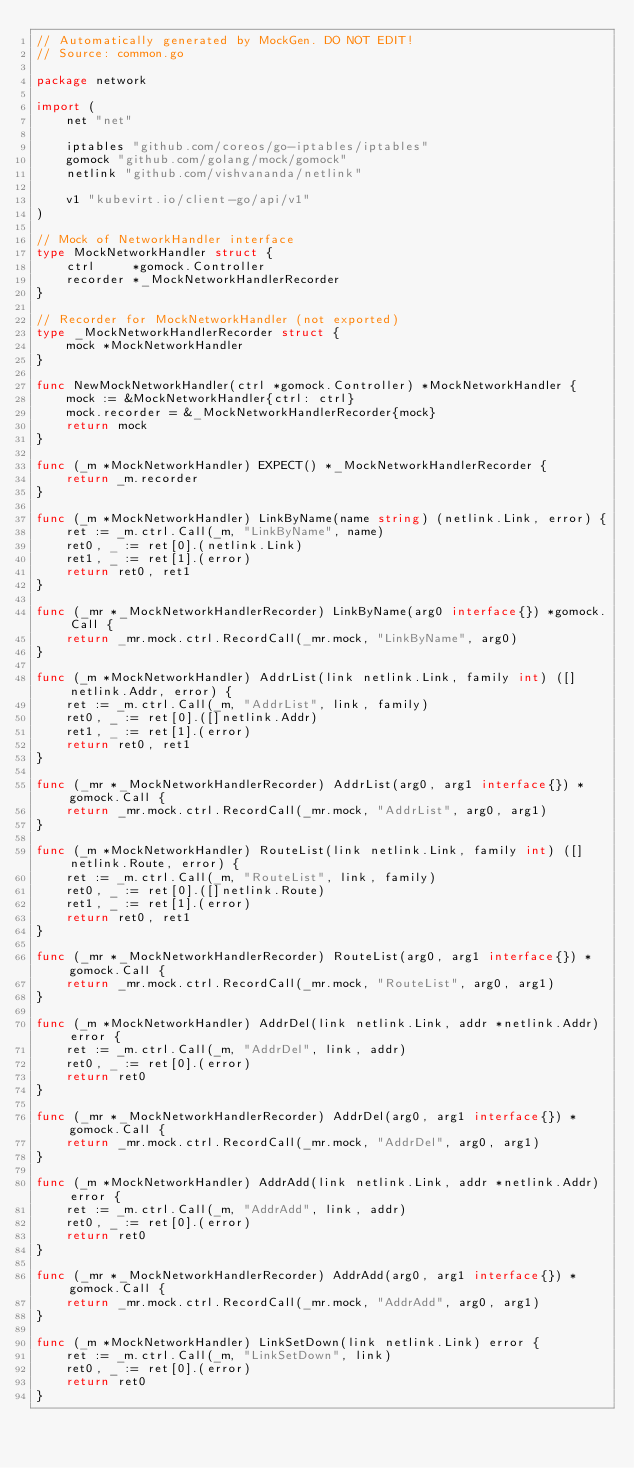<code> <loc_0><loc_0><loc_500><loc_500><_Go_>// Automatically generated by MockGen. DO NOT EDIT!
// Source: common.go

package network

import (
	net "net"

	iptables "github.com/coreos/go-iptables/iptables"
	gomock "github.com/golang/mock/gomock"
	netlink "github.com/vishvananda/netlink"

	v1 "kubevirt.io/client-go/api/v1"
)

// Mock of NetworkHandler interface
type MockNetworkHandler struct {
	ctrl     *gomock.Controller
	recorder *_MockNetworkHandlerRecorder
}

// Recorder for MockNetworkHandler (not exported)
type _MockNetworkHandlerRecorder struct {
	mock *MockNetworkHandler
}

func NewMockNetworkHandler(ctrl *gomock.Controller) *MockNetworkHandler {
	mock := &MockNetworkHandler{ctrl: ctrl}
	mock.recorder = &_MockNetworkHandlerRecorder{mock}
	return mock
}

func (_m *MockNetworkHandler) EXPECT() *_MockNetworkHandlerRecorder {
	return _m.recorder
}

func (_m *MockNetworkHandler) LinkByName(name string) (netlink.Link, error) {
	ret := _m.ctrl.Call(_m, "LinkByName", name)
	ret0, _ := ret[0].(netlink.Link)
	ret1, _ := ret[1].(error)
	return ret0, ret1
}

func (_mr *_MockNetworkHandlerRecorder) LinkByName(arg0 interface{}) *gomock.Call {
	return _mr.mock.ctrl.RecordCall(_mr.mock, "LinkByName", arg0)
}

func (_m *MockNetworkHandler) AddrList(link netlink.Link, family int) ([]netlink.Addr, error) {
	ret := _m.ctrl.Call(_m, "AddrList", link, family)
	ret0, _ := ret[0].([]netlink.Addr)
	ret1, _ := ret[1].(error)
	return ret0, ret1
}

func (_mr *_MockNetworkHandlerRecorder) AddrList(arg0, arg1 interface{}) *gomock.Call {
	return _mr.mock.ctrl.RecordCall(_mr.mock, "AddrList", arg0, arg1)
}

func (_m *MockNetworkHandler) RouteList(link netlink.Link, family int) ([]netlink.Route, error) {
	ret := _m.ctrl.Call(_m, "RouteList", link, family)
	ret0, _ := ret[0].([]netlink.Route)
	ret1, _ := ret[1].(error)
	return ret0, ret1
}

func (_mr *_MockNetworkHandlerRecorder) RouteList(arg0, arg1 interface{}) *gomock.Call {
	return _mr.mock.ctrl.RecordCall(_mr.mock, "RouteList", arg0, arg1)
}

func (_m *MockNetworkHandler) AddrDel(link netlink.Link, addr *netlink.Addr) error {
	ret := _m.ctrl.Call(_m, "AddrDel", link, addr)
	ret0, _ := ret[0].(error)
	return ret0
}

func (_mr *_MockNetworkHandlerRecorder) AddrDel(arg0, arg1 interface{}) *gomock.Call {
	return _mr.mock.ctrl.RecordCall(_mr.mock, "AddrDel", arg0, arg1)
}

func (_m *MockNetworkHandler) AddrAdd(link netlink.Link, addr *netlink.Addr) error {
	ret := _m.ctrl.Call(_m, "AddrAdd", link, addr)
	ret0, _ := ret[0].(error)
	return ret0
}

func (_mr *_MockNetworkHandlerRecorder) AddrAdd(arg0, arg1 interface{}) *gomock.Call {
	return _mr.mock.ctrl.RecordCall(_mr.mock, "AddrAdd", arg0, arg1)
}

func (_m *MockNetworkHandler) LinkSetDown(link netlink.Link) error {
	ret := _m.ctrl.Call(_m, "LinkSetDown", link)
	ret0, _ := ret[0].(error)
	return ret0
}
</code> 